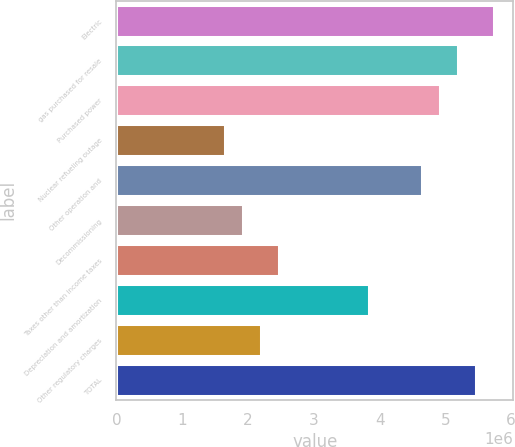Convert chart to OTSL. <chart><loc_0><loc_0><loc_500><loc_500><bar_chart><fcel>Electric<fcel>gas purchased for resale<fcel>Purchased power<fcel>Nuclear refueling outage<fcel>Other operation and<fcel>Decommissioning<fcel>Taxes other than income taxes<fcel>Depreciation and amortization<fcel>Other regulatory charges<fcel>TOTAL<nl><fcel>5.74501e+06<fcel>5.1982e+06<fcel>4.9248e+06<fcel>1.64393e+06<fcel>4.65139e+06<fcel>1.91734e+06<fcel>2.46415e+06<fcel>3.83117e+06<fcel>2.19074e+06<fcel>5.47161e+06<nl></chart> 